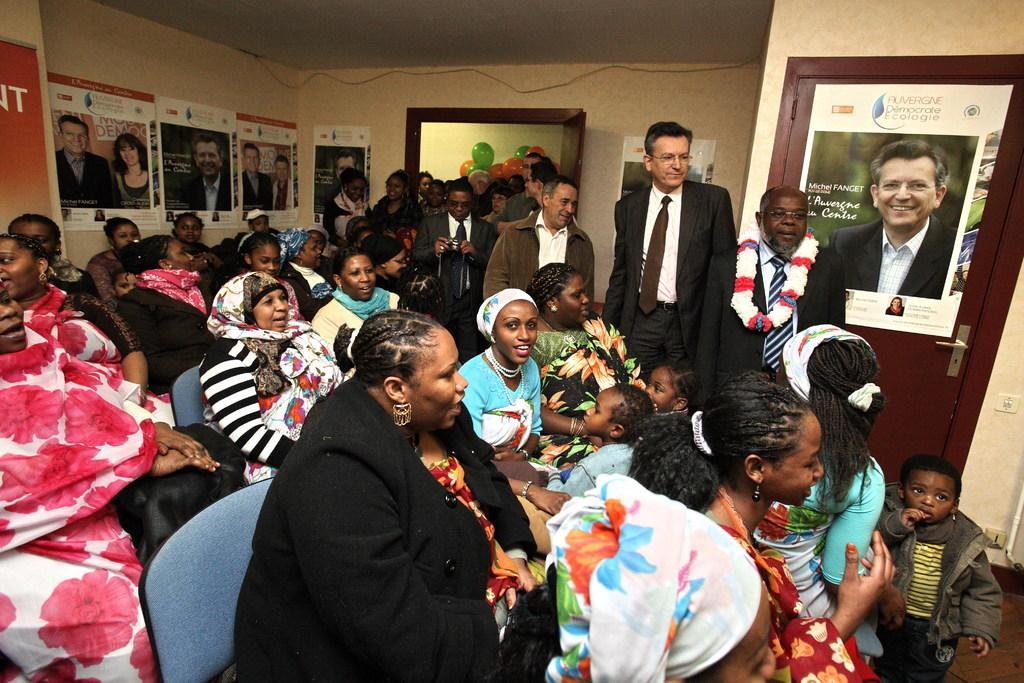Could you give a brief overview of what you see in this image? In the center of the image there are people sitting on chairs. In the background of the image there are people standing. There is a door. There are balloons. There are posters on the wall. To the right side of the image there is a poster on the door. 